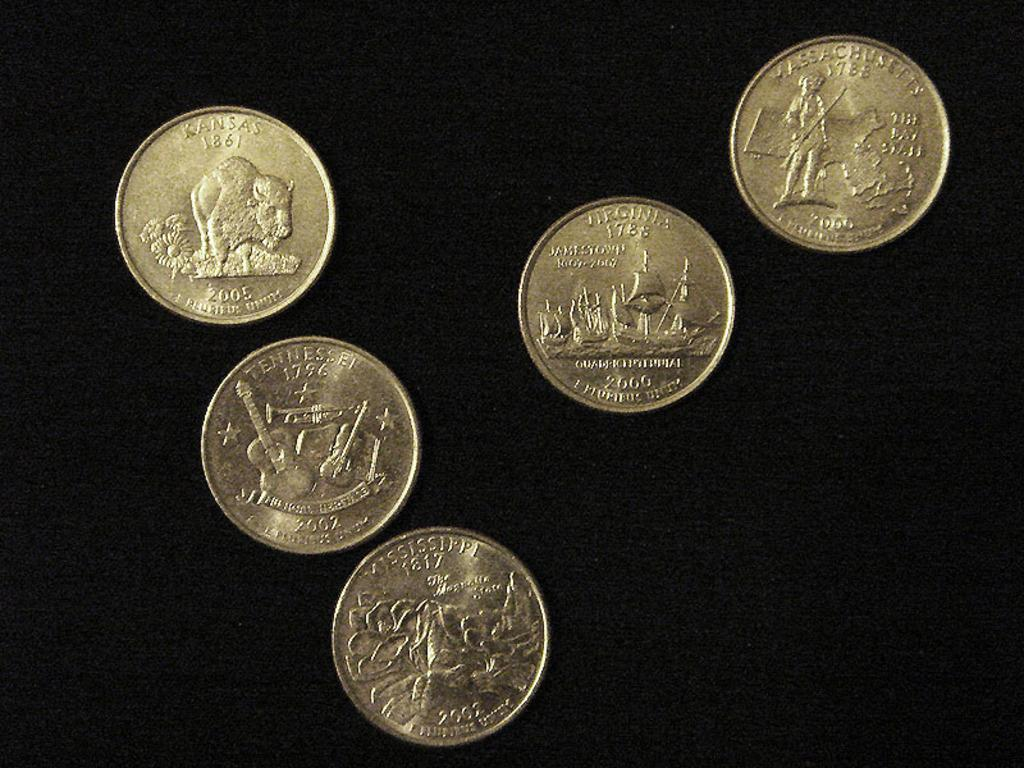<image>
Relay a brief, clear account of the picture shown. American state quarters from Kansas, Mississippi, Tennessee, Virginia and Massachusetts., 